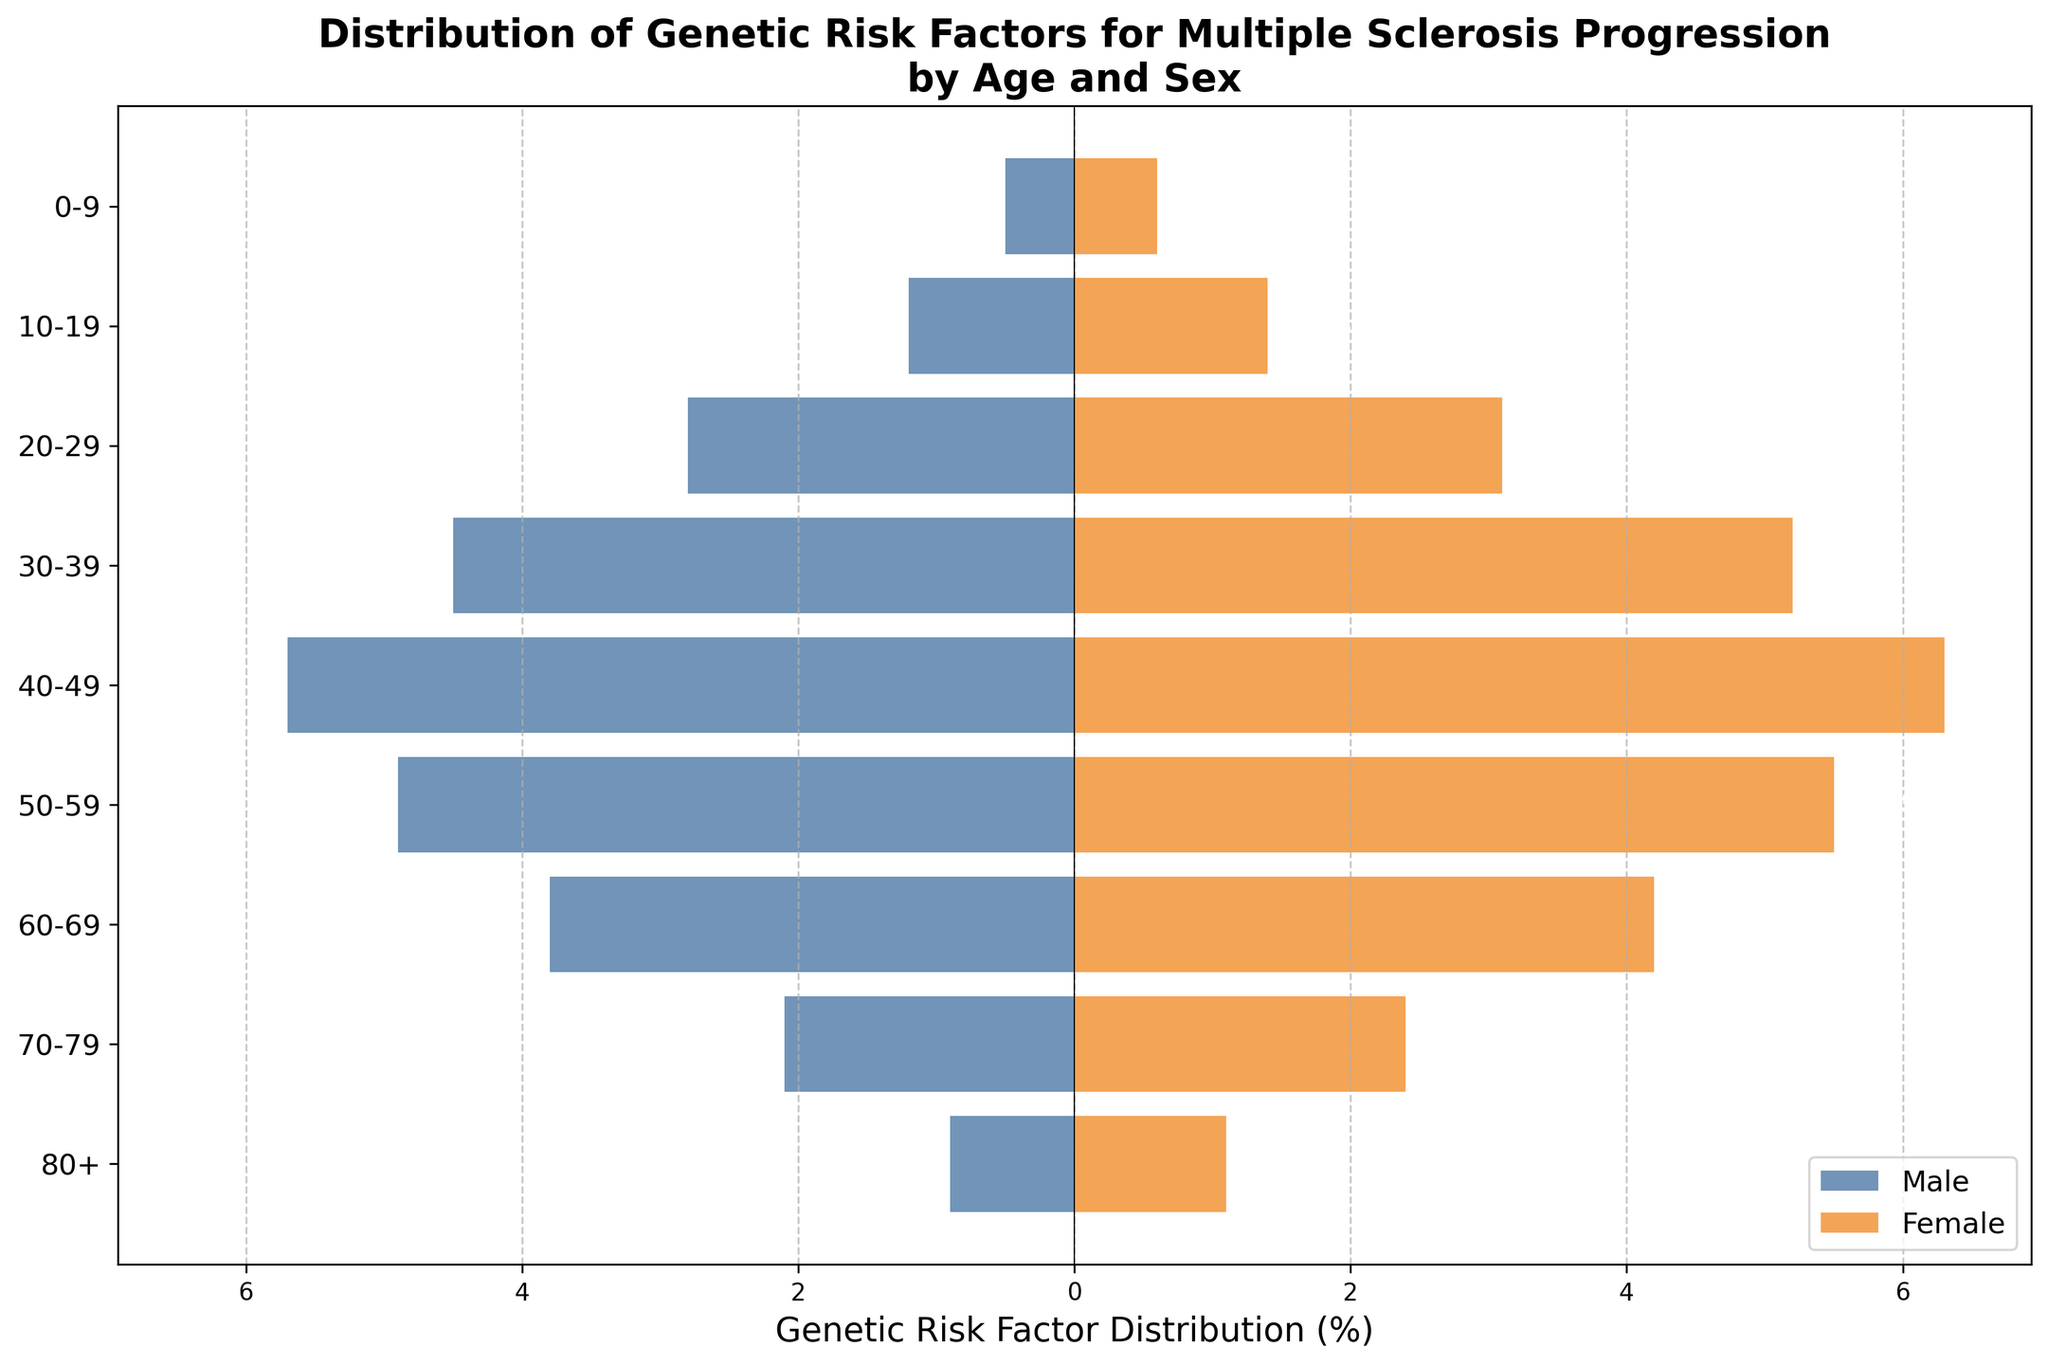What's the title of the plot? The title is prominently displayed at the top of the plot.
Answer: Distribution of Genetic Risk Factors for Multiple Sclerosis Progression by Age and Sex What is the value of the genetic risk factor for males aged 30-39? Observing the bar chart, the value is labeled on the bar corresponding to the 30-39 age group for males.
Answer: 4.5 Which age group shows the largest difference in genetic risk factors between males and females? By comparing the lengths of the bars for each age group, the largest difference is evident between males and females aged 40-49, with males at 5.7 and females at 6.3, making a difference of 1.4.
Answer: 40-49 What is the pattern of genetic risk factor distribution for females as age increases? The bars on the right side of the pyramid show a general trend of increasing risk factors for females from age 0-9 through 40-49, peaking at 40-49, then decreasing slightly.
Answer: Increases up to 40-49, then decreases At what age range is the genetic risk factor distribution closest between males and females? The differences in the bars for each age range can be assessed, and the closest values for males and females are found in the age range 70-79, with males at 2.1 and females at 2.4, making the difference 0.3.
Answer: 70-79 How many age groups show a genetic risk factor above 5 for females? Count the number of bars on the right side of the pyramid where the female values exceed 5. Only the age groups 30-39, 40-49, and 50-59 meet this criterion.
Answer: 3 What is the total genetic risk factor distribution for males in the age range 20-39? Combine the absolute values of the genetic risk factors for males aged 20-29 and 30-39: 2.8 + 4.5 = 7.3.
Answer: 7.3 Compare the genetic risk factor distributions at age 50-59 for males and females. Observe the bar lengths for this age group, noting the values for both males and females, then state the gender with the higher value. Males have 4.9, and females have 5.5, so females have a higher distribution.
Answer: Females have a higher distribution What is the value of the genetic risk factor for females aged 60-69? The value can be located by looking at the corresponding bar in the 60-69 category for females.
Answer: 4.2 